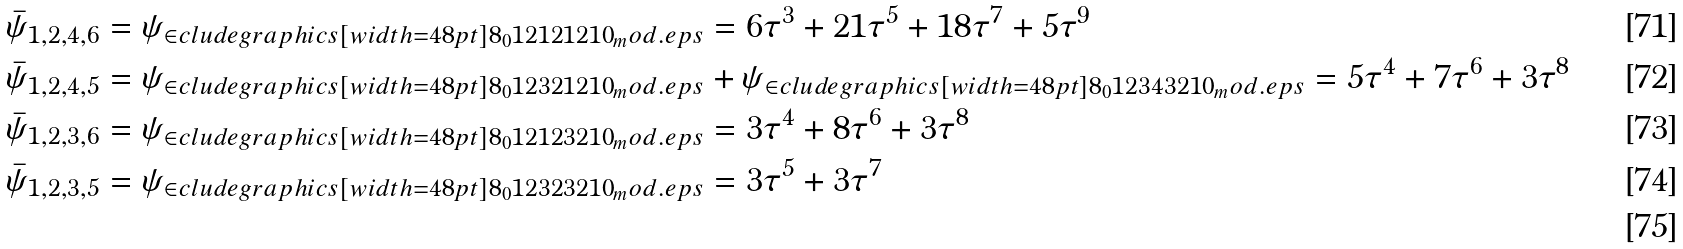Convert formula to latex. <formula><loc_0><loc_0><loc_500><loc_500>\bar { \psi } _ { 1 , 2 , 4 , 6 } & = \psi _ { \in c l u d e g r a p h i c s [ w i d t h = 4 8 p t ] { 8 _ { 0 } 1 2 1 2 1 2 1 0 _ { m } o d . e p s } } = 6 \tau ^ { 3 } + 2 1 \tau ^ { 5 } + 1 8 \tau ^ { 7 } + 5 \tau ^ { 9 } \\ \bar { \psi } _ { 1 , 2 , 4 , 5 } & = \psi _ { \in c l u d e g r a p h i c s [ w i d t h = 4 8 p t ] { 8 _ { 0 } 1 2 3 2 1 2 1 0 _ { m } o d . e p s } } + \psi _ { \in c l u d e g r a p h i c s [ w i d t h = 4 8 p t ] { 8 _ { 0 } 1 2 3 4 3 2 1 0 _ { m } o d . e p s } } = 5 \tau ^ { 4 } + 7 \tau ^ { 6 } + 3 \tau ^ { 8 } \\ \bar { \psi } _ { 1 , 2 , 3 , 6 } & = \psi _ { \in c l u d e g r a p h i c s [ w i d t h = 4 8 p t ] { 8 _ { 0 } 1 2 1 2 3 2 1 0 _ { m } o d . e p s } } = 3 \tau ^ { 4 } + 8 \tau ^ { 6 } + 3 \tau ^ { 8 } \\ \bar { \psi } _ { 1 , 2 , 3 , 5 } & = \psi _ { \in c l u d e g r a p h i c s [ w i d t h = 4 8 p t ] { 8 _ { 0 } 1 2 3 2 3 2 1 0 _ { m } o d . e p s } } = 3 \tau ^ { 5 } + 3 \tau ^ { 7 } \\</formula> 